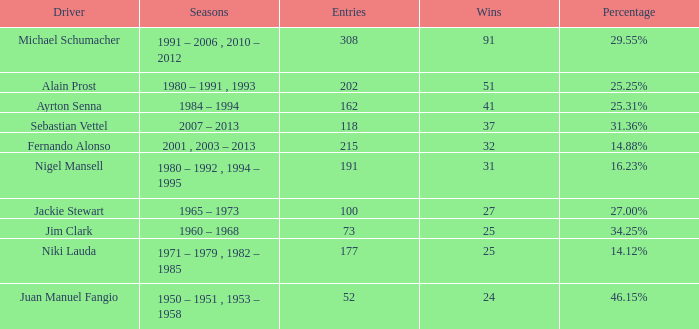Which chauffeur has less than 37 triumphs and at 1 177.0. 